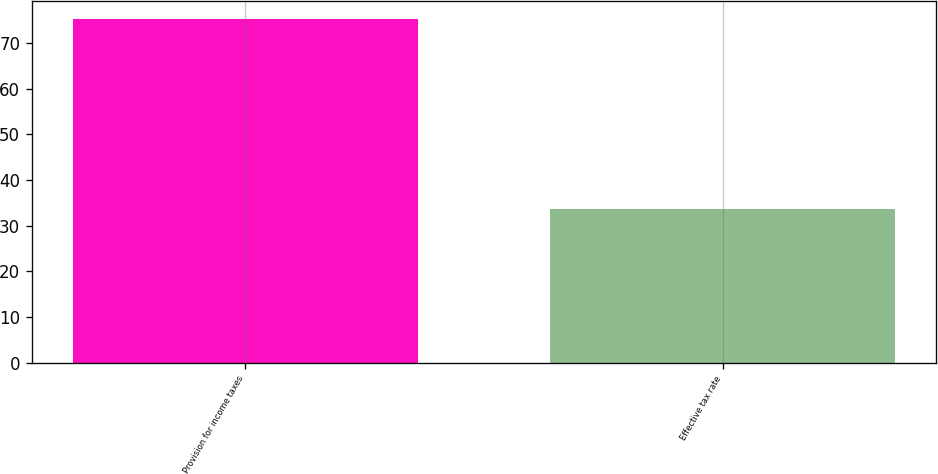Convert chart to OTSL. <chart><loc_0><loc_0><loc_500><loc_500><bar_chart><fcel>Provision for income taxes<fcel>Effective tax rate<nl><fcel>75.3<fcel>33.7<nl></chart> 